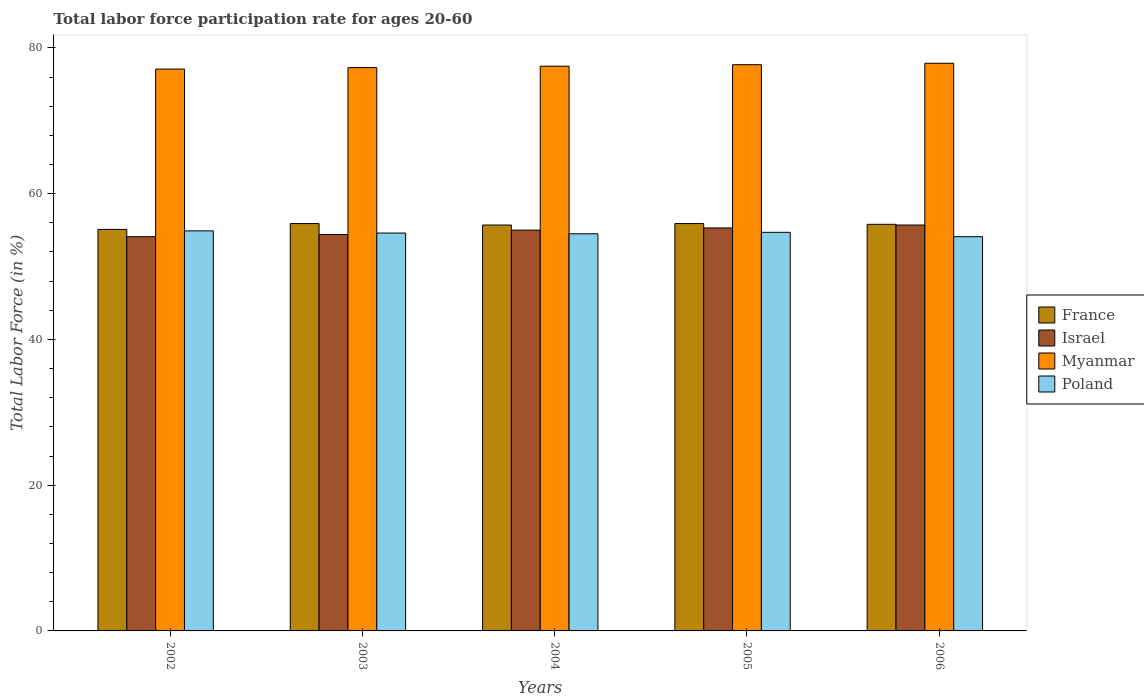Are the number of bars on each tick of the X-axis equal?
Your answer should be compact. Yes. How many bars are there on the 1st tick from the left?
Ensure brevity in your answer.  4. What is the labor force participation rate in Myanmar in 2004?
Give a very brief answer. 77.5. Across all years, what is the maximum labor force participation rate in Israel?
Your response must be concise. 55.7. Across all years, what is the minimum labor force participation rate in Myanmar?
Your answer should be very brief. 77.1. In which year was the labor force participation rate in Israel minimum?
Your response must be concise. 2002. What is the total labor force participation rate in Poland in the graph?
Offer a terse response. 272.8. What is the difference between the labor force participation rate in Poland in 2002 and that in 2006?
Your answer should be compact. 0.8. What is the difference between the labor force participation rate in France in 2005 and the labor force participation rate in Israel in 2006?
Provide a succinct answer. 0.2. What is the average labor force participation rate in Myanmar per year?
Make the answer very short. 77.5. In the year 2006, what is the difference between the labor force participation rate in Myanmar and labor force participation rate in Poland?
Offer a very short reply. 23.8. What is the ratio of the labor force participation rate in Myanmar in 2004 to that in 2005?
Your answer should be very brief. 1. Is the difference between the labor force participation rate in Myanmar in 2002 and 2003 greater than the difference between the labor force participation rate in Poland in 2002 and 2003?
Your answer should be compact. No. What is the difference between the highest and the lowest labor force participation rate in Israel?
Keep it short and to the point. 1.6. In how many years, is the labor force participation rate in Poland greater than the average labor force participation rate in Poland taken over all years?
Your response must be concise. 3. What does the 2nd bar from the left in 2006 represents?
Offer a very short reply. Israel. What does the 2nd bar from the right in 2003 represents?
Keep it short and to the point. Myanmar. Is it the case that in every year, the sum of the labor force participation rate in Myanmar and labor force participation rate in France is greater than the labor force participation rate in Poland?
Your answer should be compact. Yes. How many bars are there?
Your answer should be very brief. 20. What is the difference between two consecutive major ticks on the Y-axis?
Your response must be concise. 20. Are the values on the major ticks of Y-axis written in scientific E-notation?
Your answer should be very brief. No. Does the graph contain grids?
Give a very brief answer. No. Where does the legend appear in the graph?
Your answer should be compact. Center right. How are the legend labels stacked?
Keep it short and to the point. Vertical. What is the title of the graph?
Your response must be concise. Total labor force participation rate for ages 20-60. What is the label or title of the X-axis?
Make the answer very short. Years. What is the label or title of the Y-axis?
Your answer should be very brief. Total Labor Force (in %). What is the Total Labor Force (in %) of France in 2002?
Your answer should be very brief. 55.1. What is the Total Labor Force (in %) of Israel in 2002?
Keep it short and to the point. 54.1. What is the Total Labor Force (in %) of Myanmar in 2002?
Provide a succinct answer. 77.1. What is the Total Labor Force (in %) in Poland in 2002?
Provide a succinct answer. 54.9. What is the Total Labor Force (in %) of France in 2003?
Ensure brevity in your answer.  55.9. What is the Total Labor Force (in %) in Israel in 2003?
Provide a short and direct response. 54.4. What is the Total Labor Force (in %) in Myanmar in 2003?
Offer a very short reply. 77.3. What is the Total Labor Force (in %) of Poland in 2003?
Offer a very short reply. 54.6. What is the Total Labor Force (in %) of France in 2004?
Offer a terse response. 55.7. What is the Total Labor Force (in %) of Myanmar in 2004?
Offer a terse response. 77.5. What is the Total Labor Force (in %) in Poland in 2004?
Your answer should be very brief. 54.5. What is the Total Labor Force (in %) of France in 2005?
Make the answer very short. 55.9. What is the Total Labor Force (in %) of Israel in 2005?
Offer a very short reply. 55.3. What is the Total Labor Force (in %) in Myanmar in 2005?
Offer a very short reply. 77.7. What is the Total Labor Force (in %) of Poland in 2005?
Your answer should be compact. 54.7. What is the Total Labor Force (in %) in France in 2006?
Your answer should be very brief. 55.8. What is the Total Labor Force (in %) of Israel in 2006?
Give a very brief answer. 55.7. What is the Total Labor Force (in %) of Myanmar in 2006?
Your answer should be compact. 77.9. What is the Total Labor Force (in %) in Poland in 2006?
Your answer should be very brief. 54.1. Across all years, what is the maximum Total Labor Force (in %) of France?
Your answer should be compact. 55.9. Across all years, what is the maximum Total Labor Force (in %) of Israel?
Offer a terse response. 55.7. Across all years, what is the maximum Total Labor Force (in %) in Myanmar?
Provide a short and direct response. 77.9. Across all years, what is the maximum Total Labor Force (in %) of Poland?
Offer a very short reply. 54.9. Across all years, what is the minimum Total Labor Force (in %) in France?
Ensure brevity in your answer.  55.1. Across all years, what is the minimum Total Labor Force (in %) of Israel?
Keep it short and to the point. 54.1. Across all years, what is the minimum Total Labor Force (in %) of Myanmar?
Your response must be concise. 77.1. Across all years, what is the minimum Total Labor Force (in %) of Poland?
Ensure brevity in your answer.  54.1. What is the total Total Labor Force (in %) in France in the graph?
Make the answer very short. 278.4. What is the total Total Labor Force (in %) of Israel in the graph?
Make the answer very short. 274.5. What is the total Total Labor Force (in %) of Myanmar in the graph?
Your answer should be very brief. 387.5. What is the total Total Labor Force (in %) in Poland in the graph?
Provide a succinct answer. 272.8. What is the difference between the Total Labor Force (in %) in Israel in 2002 and that in 2003?
Give a very brief answer. -0.3. What is the difference between the Total Labor Force (in %) of Israel in 2002 and that in 2004?
Your response must be concise. -0.9. What is the difference between the Total Labor Force (in %) in Poland in 2002 and that in 2004?
Your answer should be very brief. 0.4. What is the difference between the Total Labor Force (in %) of France in 2002 and that in 2005?
Your answer should be compact. -0.8. What is the difference between the Total Labor Force (in %) of Myanmar in 2002 and that in 2005?
Your answer should be very brief. -0.6. What is the difference between the Total Labor Force (in %) of Poland in 2002 and that in 2005?
Your answer should be compact. 0.2. What is the difference between the Total Labor Force (in %) of Poland in 2002 and that in 2006?
Ensure brevity in your answer.  0.8. What is the difference between the Total Labor Force (in %) in Poland in 2003 and that in 2004?
Ensure brevity in your answer.  0.1. What is the difference between the Total Labor Force (in %) in Myanmar in 2003 and that in 2006?
Offer a terse response. -0.6. What is the difference between the Total Labor Force (in %) of Poland in 2003 and that in 2006?
Your answer should be very brief. 0.5. What is the difference between the Total Labor Force (in %) of Israel in 2004 and that in 2005?
Offer a terse response. -0.3. What is the difference between the Total Labor Force (in %) of Israel in 2004 and that in 2006?
Provide a short and direct response. -0.7. What is the difference between the Total Labor Force (in %) of Myanmar in 2004 and that in 2006?
Your answer should be compact. -0.4. What is the difference between the Total Labor Force (in %) of France in 2002 and the Total Labor Force (in %) of Israel in 2003?
Keep it short and to the point. 0.7. What is the difference between the Total Labor Force (in %) of France in 2002 and the Total Labor Force (in %) of Myanmar in 2003?
Provide a succinct answer. -22.2. What is the difference between the Total Labor Force (in %) in Israel in 2002 and the Total Labor Force (in %) in Myanmar in 2003?
Provide a succinct answer. -23.2. What is the difference between the Total Labor Force (in %) of Myanmar in 2002 and the Total Labor Force (in %) of Poland in 2003?
Your answer should be compact. 22.5. What is the difference between the Total Labor Force (in %) of France in 2002 and the Total Labor Force (in %) of Myanmar in 2004?
Your answer should be very brief. -22.4. What is the difference between the Total Labor Force (in %) in France in 2002 and the Total Labor Force (in %) in Poland in 2004?
Ensure brevity in your answer.  0.6. What is the difference between the Total Labor Force (in %) of Israel in 2002 and the Total Labor Force (in %) of Myanmar in 2004?
Give a very brief answer. -23.4. What is the difference between the Total Labor Force (in %) in Israel in 2002 and the Total Labor Force (in %) in Poland in 2004?
Keep it short and to the point. -0.4. What is the difference between the Total Labor Force (in %) of Myanmar in 2002 and the Total Labor Force (in %) of Poland in 2004?
Your response must be concise. 22.6. What is the difference between the Total Labor Force (in %) in France in 2002 and the Total Labor Force (in %) in Israel in 2005?
Your answer should be very brief. -0.2. What is the difference between the Total Labor Force (in %) in France in 2002 and the Total Labor Force (in %) in Myanmar in 2005?
Give a very brief answer. -22.6. What is the difference between the Total Labor Force (in %) in Israel in 2002 and the Total Labor Force (in %) in Myanmar in 2005?
Ensure brevity in your answer.  -23.6. What is the difference between the Total Labor Force (in %) in Israel in 2002 and the Total Labor Force (in %) in Poland in 2005?
Provide a succinct answer. -0.6. What is the difference between the Total Labor Force (in %) of Myanmar in 2002 and the Total Labor Force (in %) of Poland in 2005?
Make the answer very short. 22.4. What is the difference between the Total Labor Force (in %) in France in 2002 and the Total Labor Force (in %) in Myanmar in 2006?
Make the answer very short. -22.8. What is the difference between the Total Labor Force (in %) of France in 2002 and the Total Labor Force (in %) of Poland in 2006?
Your answer should be compact. 1. What is the difference between the Total Labor Force (in %) in Israel in 2002 and the Total Labor Force (in %) in Myanmar in 2006?
Your answer should be compact. -23.8. What is the difference between the Total Labor Force (in %) in Israel in 2002 and the Total Labor Force (in %) in Poland in 2006?
Provide a succinct answer. 0. What is the difference between the Total Labor Force (in %) in Myanmar in 2002 and the Total Labor Force (in %) in Poland in 2006?
Provide a succinct answer. 23. What is the difference between the Total Labor Force (in %) of France in 2003 and the Total Labor Force (in %) of Myanmar in 2004?
Give a very brief answer. -21.6. What is the difference between the Total Labor Force (in %) of France in 2003 and the Total Labor Force (in %) of Poland in 2004?
Your response must be concise. 1.4. What is the difference between the Total Labor Force (in %) in Israel in 2003 and the Total Labor Force (in %) in Myanmar in 2004?
Provide a succinct answer. -23.1. What is the difference between the Total Labor Force (in %) in Myanmar in 2003 and the Total Labor Force (in %) in Poland in 2004?
Make the answer very short. 22.8. What is the difference between the Total Labor Force (in %) in France in 2003 and the Total Labor Force (in %) in Myanmar in 2005?
Provide a succinct answer. -21.8. What is the difference between the Total Labor Force (in %) in France in 2003 and the Total Labor Force (in %) in Poland in 2005?
Your answer should be compact. 1.2. What is the difference between the Total Labor Force (in %) in Israel in 2003 and the Total Labor Force (in %) in Myanmar in 2005?
Provide a short and direct response. -23.3. What is the difference between the Total Labor Force (in %) of Israel in 2003 and the Total Labor Force (in %) of Poland in 2005?
Your answer should be compact. -0.3. What is the difference between the Total Labor Force (in %) in Myanmar in 2003 and the Total Labor Force (in %) in Poland in 2005?
Keep it short and to the point. 22.6. What is the difference between the Total Labor Force (in %) in France in 2003 and the Total Labor Force (in %) in Israel in 2006?
Your answer should be very brief. 0.2. What is the difference between the Total Labor Force (in %) in France in 2003 and the Total Labor Force (in %) in Myanmar in 2006?
Your response must be concise. -22. What is the difference between the Total Labor Force (in %) in France in 2003 and the Total Labor Force (in %) in Poland in 2006?
Your answer should be very brief. 1.8. What is the difference between the Total Labor Force (in %) in Israel in 2003 and the Total Labor Force (in %) in Myanmar in 2006?
Offer a terse response. -23.5. What is the difference between the Total Labor Force (in %) of Myanmar in 2003 and the Total Labor Force (in %) of Poland in 2006?
Your response must be concise. 23.2. What is the difference between the Total Labor Force (in %) of France in 2004 and the Total Labor Force (in %) of Israel in 2005?
Offer a very short reply. 0.4. What is the difference between the Total Labor Force (in %) in France in 2004 and the Total Labor Force (in %) in Poland in 2005?
Offer a terse response. 1. What is the difference between the Total Labor Force (in %) of Israel in 2004 and the Total Labor Force (in %) of Myanmar in 2005?
Offer a very short reply. -22.7. What is the difference between the Total Labor Force (in %) of Israel in 2004 and the Total Labor Force (in %) of Poland in 2005?
Give a very brief answer. 0.3. What is the difference between the Total Labor Force (in %) in Myanmar in 2004 and the Total Labor Force (in %) in Poland in 2005?
Provide a succinct answer. 22.8. What is the difference between the Total Labor Force (in %) of France in 2004 and the Total Labor Force (in %) of Israel in 2006?
Your response must be concise. 0. What is the difference between the Total Labor Force (in %) of France in 2004 and the Total Labor Force (in %) of Myanmar in 2006?
Provide a short and direct response. -22.2. What is the difference between the Total Labor Force (in %) of France in 2004 and the Total Labor Force (in %) of Poland in 2006?
Keep it short and to the point. 1.6. What is the difference between the Total Labor Force (in %) in Israel in 2004 and the Total Labor Force (in %) in Myanmar in 2006?
Offer a terse response. -22.9. What is the difference between the Total Labor Force (in %) of Myanmar in 2004 and the Total Labor Force (in %) of Poland in 2006?
Ensure brevity in your answer.  23.4. What is the difference between the Total Labor Force (in %) in France in 2005 and the Total Labor Force (in %) in Israel in 2006?
Offer a terse response. 0.2. What is the difference between the Total Labor Force (in %) in Israel in 2005 and the Total Labor Force (in %) in Myanmar in 2006?
Ensure brevity in your answer.  -22.6. What is the difference between the Total Labor Force (in %) of Israel in 2005 and the Total Labor Force (in %) of Poland in 2006?
Make the answer very short. 1.2. What is the difference between the Total Labor Force (in %) of Myanmar in 2005 and the Total Labor Force (in %) of Poland in 2006?
Your answer should be very brief. 23.6. What is the average Total Labor Force (in %) in France per year?
Ensure brevity in your answer.  55.68. What is the average Total Labor Force (in %) in Israel per year?
Your answer should be compact. 54.9. What is the average Total Labor Force (in %) of Myanmar per year?
Provide a short and direct response. 77.5. What is the average Total Labor Force (in %) in Poland per year?
Offer a very short reply. 54.56. In the year 2002, what is the difference between the Total Labor Force (in %) of France and Total Labor Force (in %) of Poland?
Make the answer very short. 0.2. In the year 2002, what is the difference between the Total Labor Force (in %) of Israel and Total Labor Force (in %) of Myanmar?
Make the answer very short. -23. In the year 2002, what is the difference between the Total Labor Force (in %) in Israel and Total Labor Force (in %) in Poland?
Give a very brief answer. -0.8. In the year 2002, what is the difference between the Total Labor Force (in %) in Myanmar and Total Labor Force (in %) in Poland?
Your answer should be very brief. 22.2. In the year 2003, what is the difference between the Total Labor Force (in %) of France and Total Labor Force (in %) of Israel?
Provide a succinct answer. 1.5. In the year 2003, what is the difference between the Total Labor Force (in %) in France and Total Labor Force (in %) in Myanmar?
Offer a terse response. -21.4. In the year 2003, what is the difference between the Total Labor Force (in %) of Israel and Total Labor Force (in %) of Myanmar?
Your answer should be very brief. -22.9. In the year 2003, what is the difference between the Total Labor Force (in %) of Israel and Total Labor Force (in %) of Poland?
Keep it short and to the point. -0.2. In the year 2003, what is the difference between the Total Labor Force (in %) in Myanmar and Total Labor Force (in %) in Poland?
Your response must be concise. 22.7. In the year 2004, what is the difference between the Total Labor Force (in %) in France and Total Labor Force (in %) in Myanmar?
Provide a succinct answer. -21.8. In the year 2004, what is the difference between the Total Labor Force (in %) in Israel and Total Labor Force (in %) in Myanmar?
Offer a terse response. -22.5. In the year 2004, what is the difference between the Total Labor Force (in %) of Myanmar and Total Labor Force (in %) of Poland?
Make the answer very short. 23. In the year 2005, what is the difference between the Total Labor Force (in %) in France and Total Labor Force (in %) in Israel?
Make the answer very short. 0.6. In the year 2005, what is the difference between the Total Labor Force (in %) in France and Total Labor Force (in %) in Myanmar?
Your answer should be very brief. -21.8. In the year 2005, what is the difference between the Total Labor Force (in %) in France and Total Labor Force (in %) in Poland?
Provide a succinct answer. 1.2. In the year 2005, what is the difference between the Total Labor Force (in %) of Israel and Total Labor Force (in %) of Myanmar?
Make the answer very short. -22.4. In the year 2006, what is the difference between the Total Labor Force (in %) of France and Total Labor Force (in %) of Israel?
Offer a terse response. 0.1. In the year 2006, what is the difference between the Total Labor Force (in %) in France and Total Labor Force (in %) in Myanmar?
Give a very brief answer. -22.1. In the year 2006, what is the difference between the Total Labor Force (in %) in Israel and Total Labor Force (in %) in Myanmar?
Make the answer very short. -22.2. In the year 2006, what is the difference between the Total Labor Force (in %) in Israel and Total Labor Force (in %) in Poland?
Offer a very short reply. 1.6. In the year 2006, what is the difference between the Total Labor Force (in %) of Myanmar and Total Labor Force (in %) of Poland?
Provide a succinct answer. 23.8. What is the ratio of the Total Labor Force (in %) in France in 2002 to that in 2003?
Keep it short and to the point. 0.99. What is the ratio of the Total Labor Force (in %) of Israel in 2002 to that in 2003?
Offer a very short reply. 0.99. What is the ratio of the Total Labor Force (in %) in Myanmar in 2002 to that in 2003?
Ensure brevity in your answer.  1. What is the ratio of the Total Labor Force (in %) of Poland in 2002 to that in 2003?
Provide a succinct answer. 1.01. What is the ratio of the Total Labor Force (in %) in Israel in 2002 to that in 2004?
Offer a very short reply. 0.98. What is the ratio of the Total Labor Force (in %) in Myanmar in 2002 to that in 2004?
Give a very brief answer. 0.99. What is the ratio of the Total Labor Force (in %) in Poland in 2002 to that in 2004?
Your answer should be compact. 1.01. What is the ratio of the Total Labor Force (in %) of France in 2002 to that in 2005?
Make the answer very short. 0.99. What is the ratio of the Total Labor Force (in %) in Israel in 2002 to that in 2005?
Give a very brief answer. 0.98. What is the ratio of the Total Labor Force (in %) of France in 2002 to that in 2006?
Provide a short and direct response. 0.99. What is the ratio of the Total Labor Force (in %) of Israel in 2002 to that in 2006?
Ensure brevity in your answer.  0.97. What is the ratio of the Total Labor Force (in %) of Poland in 2002 to that in 2006?
Your response must be concise. 1.01. What is the ratio of the Total Labor Force (in %) of Israel in 2003 to that in 2004?
Ensure brevity in your answer.  0.99. What is the ratio of the Total Labor Force (in %) of Poland in 2003 to that in 2004?
Your answer should be very brief. 1. What is the ratio of the Total Labor Force (in %) in France in 2003 to that in 2005?
Provide a succinct answer. 1. What is the ratio of the Total Labor Force (in %) of Israel in 2003 to that in 2005?
Provide a short and direct response. 0.98. What is the ratio of the Total Labor Force (in %) in France in 2003 to that in 2006?
Your answer should be compact. 1. What is the ratio of the Total Labor Force (in %) of Israel in 2003 to that in 2006?
Offer a very short reply. 0.98. What is the ratio of the Total Labor Force (in %) in Myanmar in 2003 to that in 2006?
Offer a terse response. 0.99. What is the ratio of the Total Labor Force (in %) in Poland in 2003 to that in 2006?
Your response must be concise. 1.01. What is the ratio of the Total Labor Force (in %) in France in 2004 to that in 2005?
Make the answer very short. 1. What is the ratio of the Total Labor Force (in %) in Myanmar in 2004 to that in 2005?
Your answer should be very brief. 1. What is the ratio of the Total Labor Force (in %) in France in 2004 to that in 2006?
Keep it short and to the point. 1. What is the ratio of the Total Labor Force (in %) in Israel in 2004 to that in 2006?
Give a very brief answer. 0.99. What is the ratio of the Total Labor Force (in %) in Myanmar in 2004 to that in 2006?
Your answer should be very brief. 0.99. What is the ratio of the Total Labor Force (in %) in Poland in 2004 to that in 2006?
Offer a very short reply. 1.01. What is the ratio of the Total Labor Force (in %) of Poland in 2005 to that in 2006?
Offer a terse response. 1.01. What is the difference between the highest and the second highest Total Labor Force (in %) in Myanmar?
Your response must be concise. 0.2. What is the difference between the highest and the lowest Total Labor Force (in %) in France?
Provide a short and direct response. 0.8. What is the difference between the highest and the lowest Total Labor Force (in %) of Myanmar?
Provide a short and direct response. 0.8. What is the difference between the highest and the lowest Total Labor Force (in %) in Poland?
Keep it short and to the point. 0.8. 